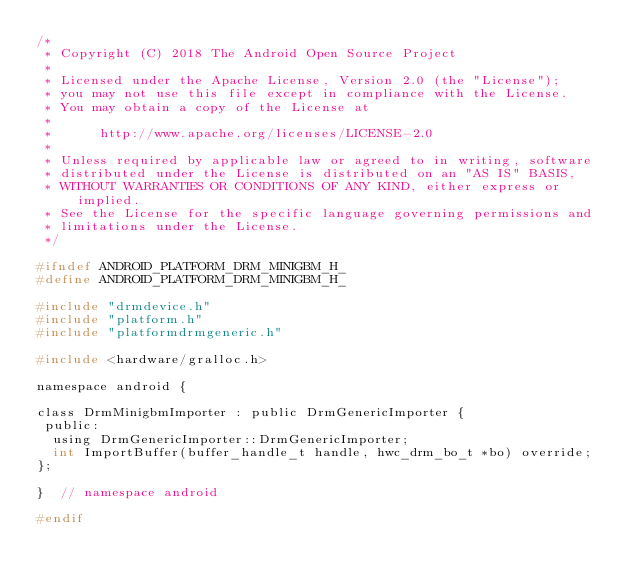Convert code to text. <code><loc_0><loc_0><loc_500><loc_500><_C_>/*
 * Copyright (C) 2018 The Android Open Source Project
 *
 * Licensed under the Apache License, Version 2.0 (the "License");
 * you may not use this file except in compliance with the License.
 * You may obtain a copy of the License at
 *
 *      http://www.apache.org/licenses/LICENSE-2.0
 *
 * Unless required by applicable law or agreed to in writing, software
 * distributed under the License is distributed on an "AS IS" BASIS,
 * WITHOUT WARRANTIES OR CONDITIONS OF ANY KIND, either express or implied.
 * See the License for the specific language governing permissions and
 * limitations under the License.
 */

#ifndef ANDROID_PLATFORM_DRM_MINIGBM_H_
#define ANDROID_PLATFORM_DRM_MINIGBM_H_

#include "drmdevice.h"
#include "platform.h"
#include "platformdrmgeneric.h"

#include <hardware/gralloc.h>

namespace android {

class DrmMinigbmImporter : public DrmGenericImporter {
 public:
  using DrmGenericImporter::DrmGenericImporter;
  int ImportBuffer(buffer_handle_t handle, hwc_drm_bo_t *bo) override;
};

}  // namespace android

#endif
</code> 